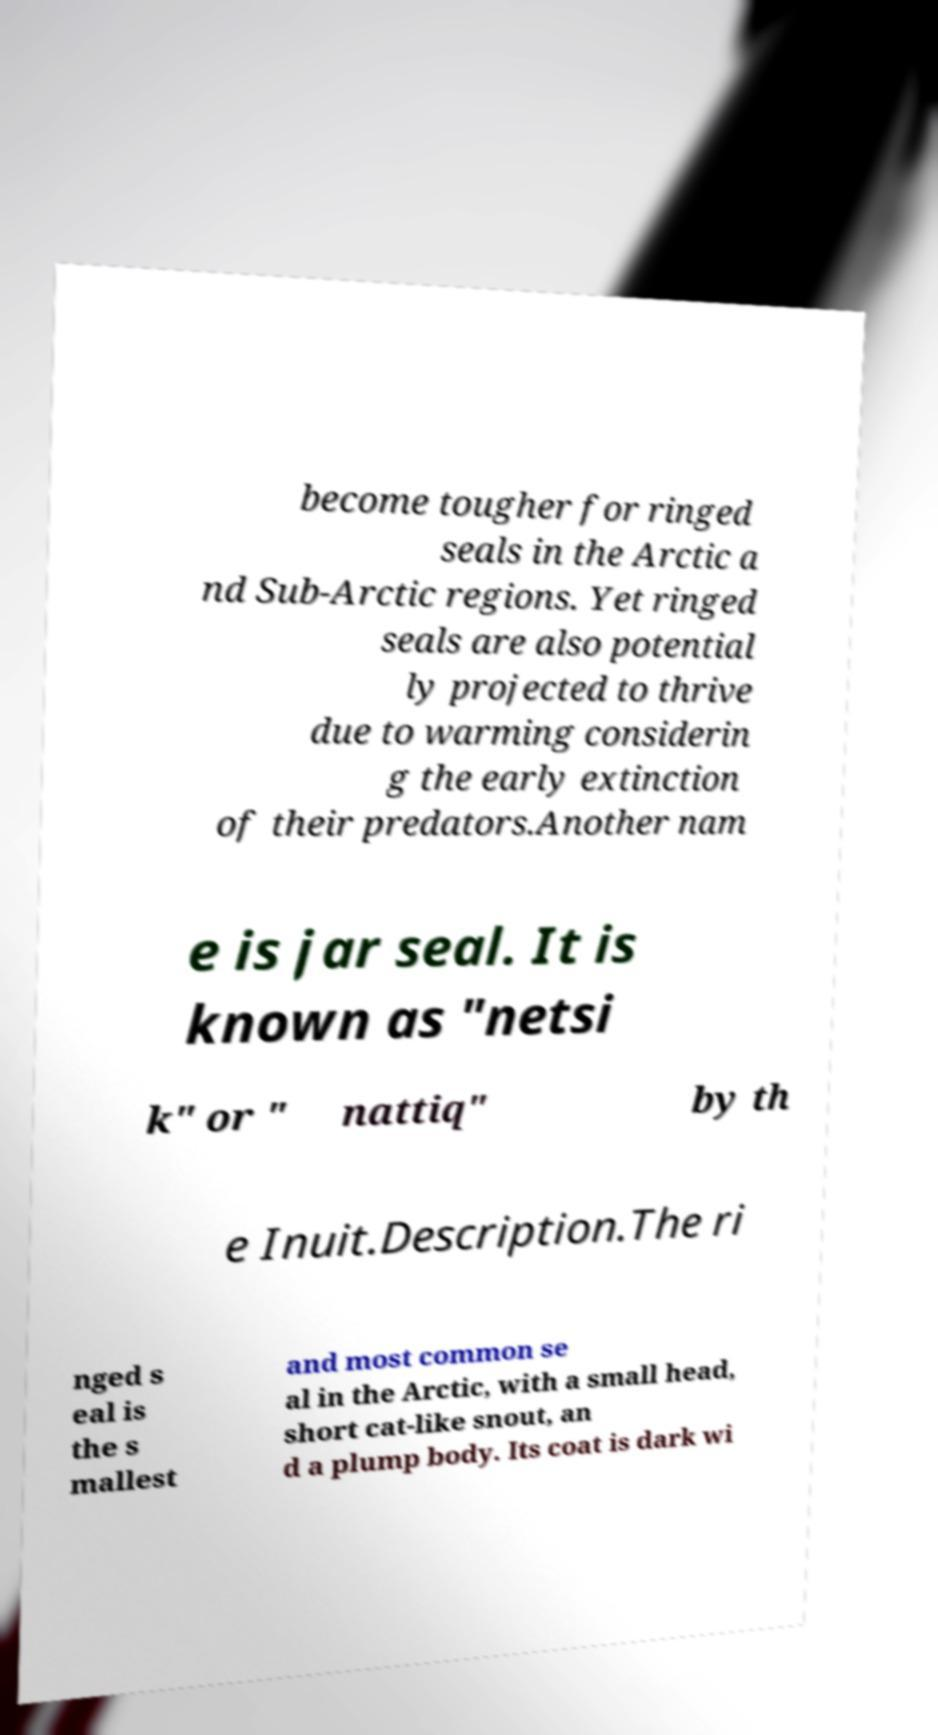There's text embedded in this image that I need extracted. Can you transcribe it verbatim? become tougher for ringed seals in the Arctic a nd Sub-Arctic regions. Yet ringed seals are also potential ly projected to thrive due to warming considerin g the early extinction of their predators.Another nam e is jar seal. It is known as "netsi k" or " nattiq" by th e Inuit.Description.The ri nged s eal is the s mallest and most common se al in the Arctic, with a small head, short cat-like snout, an d a plump body. Its coat is dark wi 